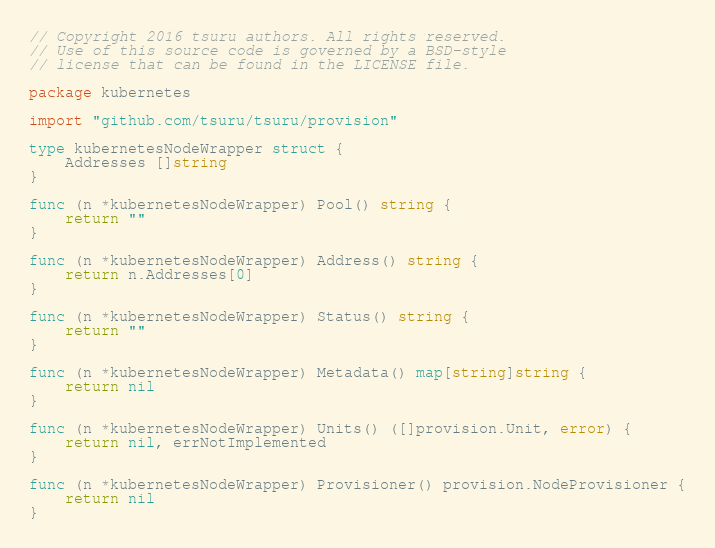<code> <loc_0><loc_0><loc_500><loc_500><_Go_>// Copyright 2016 tsuru authors. All rights reserved.
// Use of this source code is governed by a BSD-style
// license that can be found in the LICENSE file.

package kubernetes

import "github.com/tsuru/tsuru/provision"

type kubernetesNodeWrapper struct {
	Addresses []string
}

func (n *kubernetesNodeWrapper) Pool() string {
	return ""
}

func (n *kubernetesNodeWrapper) Address() string {
	return n.Addresses[0]
}

func (n *kubernetesNodeWrapper) Status() string {
	return ""
}

func (n *kubernetesNodeWrapper) Metadata() map[string]string {
	return nil
}

func (n *kubernetesNodeWrapper) Units() ([]provision.Unit, error) {
	return nil, errNotImplemented
}

func (n *kubernetesNodeWrapper) Provisioner() provision.NodeProvisioner {
	return nil
}
</code> 